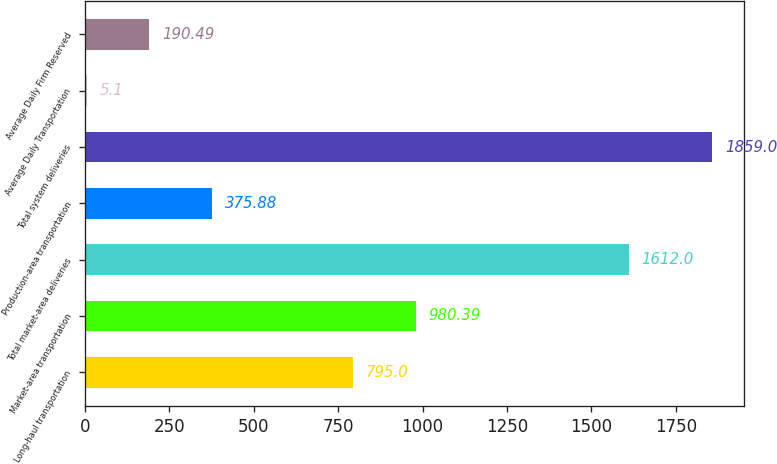Convert chart to OTSL. <chart><loc_0><loc_0><loc_500><loc_500><bar_chart><fcel>Long-haul transportation<fcel>Market-area transportation<fcel>Total market-area deliveries<fcel>Production-area transportation<fcel>Total system deliveries<fcel>Average Daily Transportation<fcel>Average Daily Firm Reserved<nl><fcel>795<fcel>980.39<fcel>1612<fcel>375.88<fcel>1859<fcel>5.1<fcel>190.49<nl></chart> 